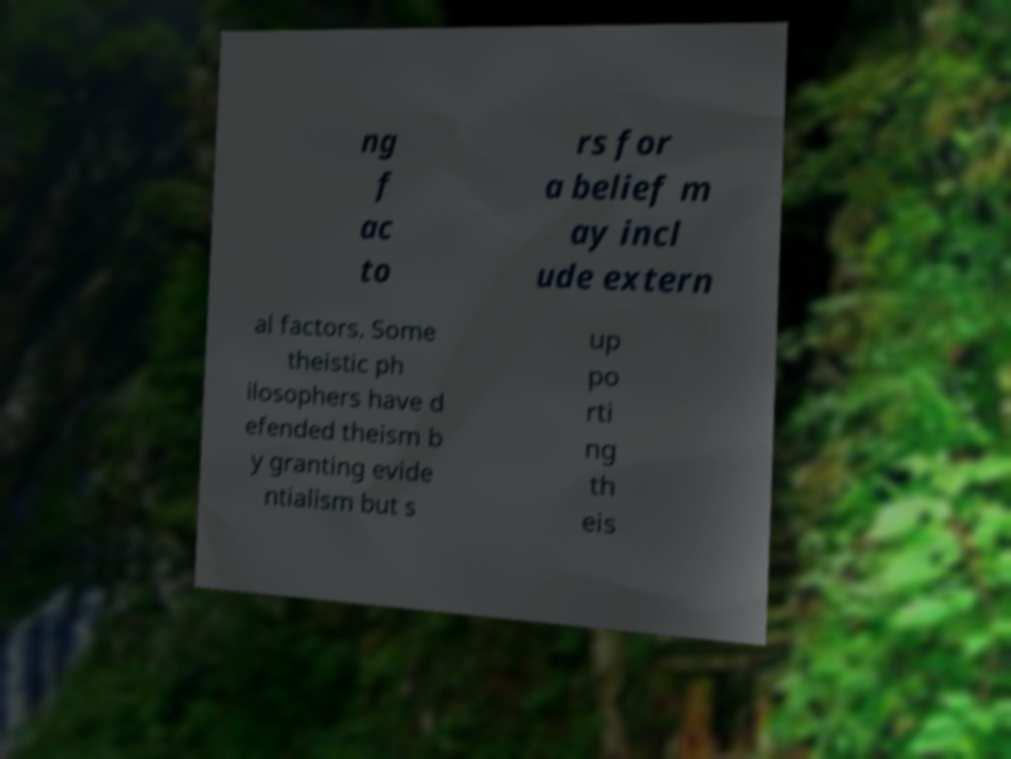I need the written content from this picture converted into text. Can you do that? ng f ac to rs for a belief m ay incl ude extern al factors. Some theistic ph ilosophers have d efended theism b y granting evide ntialism but s up po rti ng th eis 